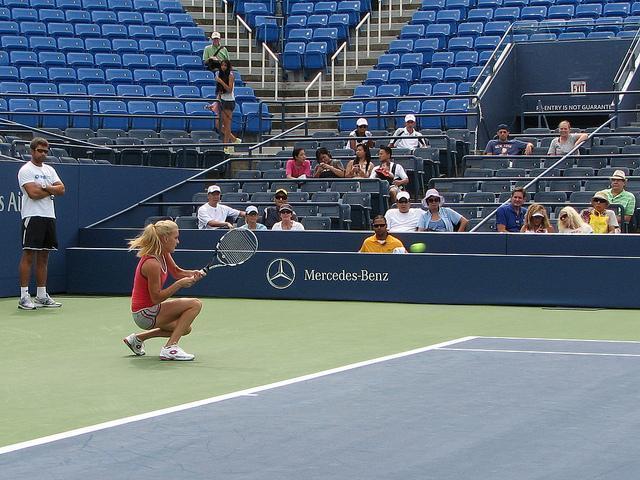How many people can be seen?
Give a very brief answer. 3. How many teddy bears are brown?
Give a very brief answer. 0. 